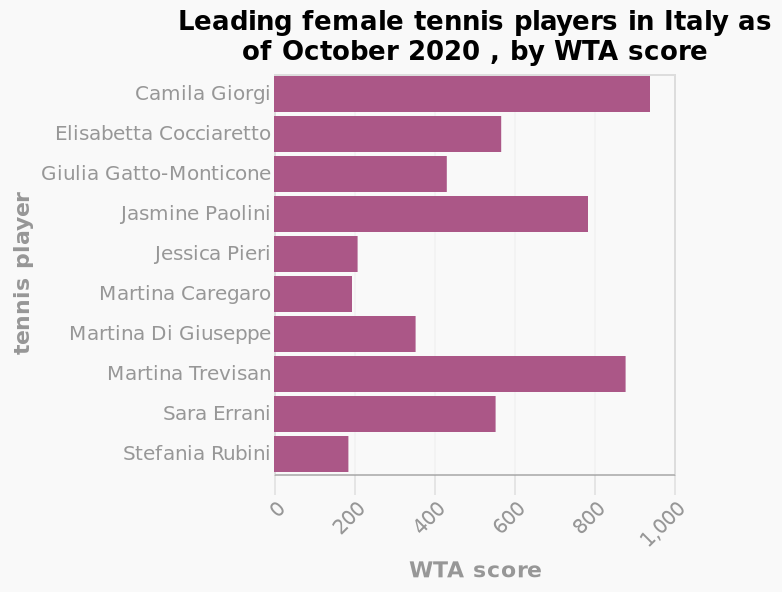<image>
What does the y-axis represent on the bar diagram? The y-axis on the bar diagram represents the tennis players in Italy on a categorical scale, with Camila Giorgi on one end and Stefania Rubini on the other. Are there any players listed with less than 300 points? The description does not provide information about the presence or absence of players with less than 300 points. Who is the leading female tennis player in Italy as of October 2020 according to the WTA score?  The leading female tennis player in Italy as of October 2020, according to the WTA score, is Camila Giorgi. 